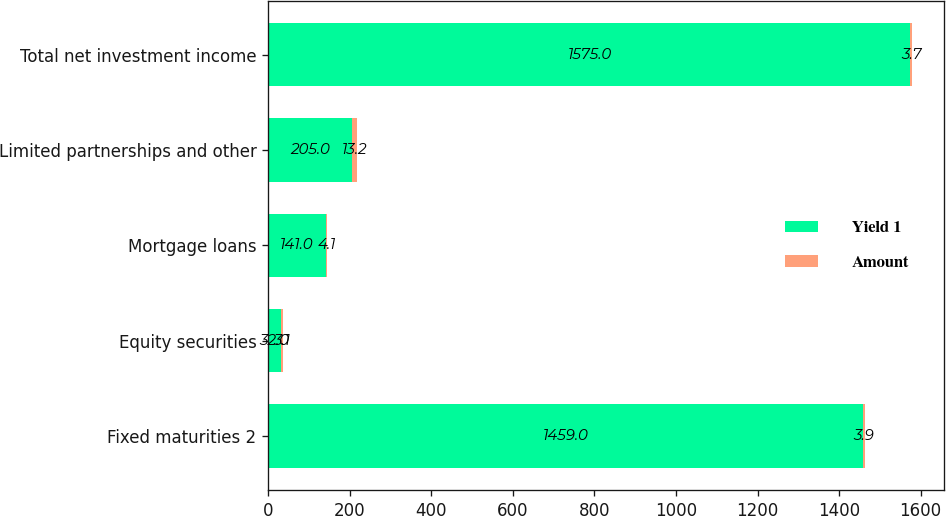Convert chart. <chart><loc_0><loc_0><loc_500><loc_500><stacked_bar_chart><ecel><fcel>Fixed maturities 2<fcel>Equity securities<fcel>Mortgage loans<fcel>Limited partnerships and other<fcel>Total net investment income<nl><fcel>Yield 1<fcel>1459<fcel>32<fcel>141<fcel>205<fcel>1575<nl><fcel>Amount<fcel>3.9<fcel>3.1<fcel>4.1<fcel>13.2<fcel>3.7<nl></chart> 